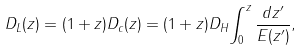<formula> <loc_0><loc_0><loc_500><loc_500>D _ { L } ( z ) = ( 1 + z ) D _ { c } ( z ) = ( 1 + z ) D _ { H } { \int _ { 0 } ^ { z } { \frac { d z ^ { \prime } } { E ( z ^ { \prime } ) } } } ,</formula> 